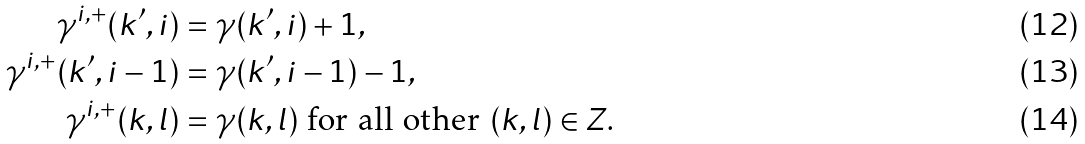Convert formula to latex. <formula><loc_0><loc_0><loc_500><loc_500>\gamma ^ { i , + } ( k ^ { \prime } , i ) & = \gamma ( k ^ { \prime } , i ) + 1 , \\ \gamma ^ { i , + } ( k ^ { \prime } , i - 1 ) & = \gamma ( k ^ { \prime } , i - 1 ) - 1 , \\ \gamma ^ { i , + } ( k , l ) & = \gamma ( k , l ) \text { for all other } ( k , l ) \in Z .</formula> 